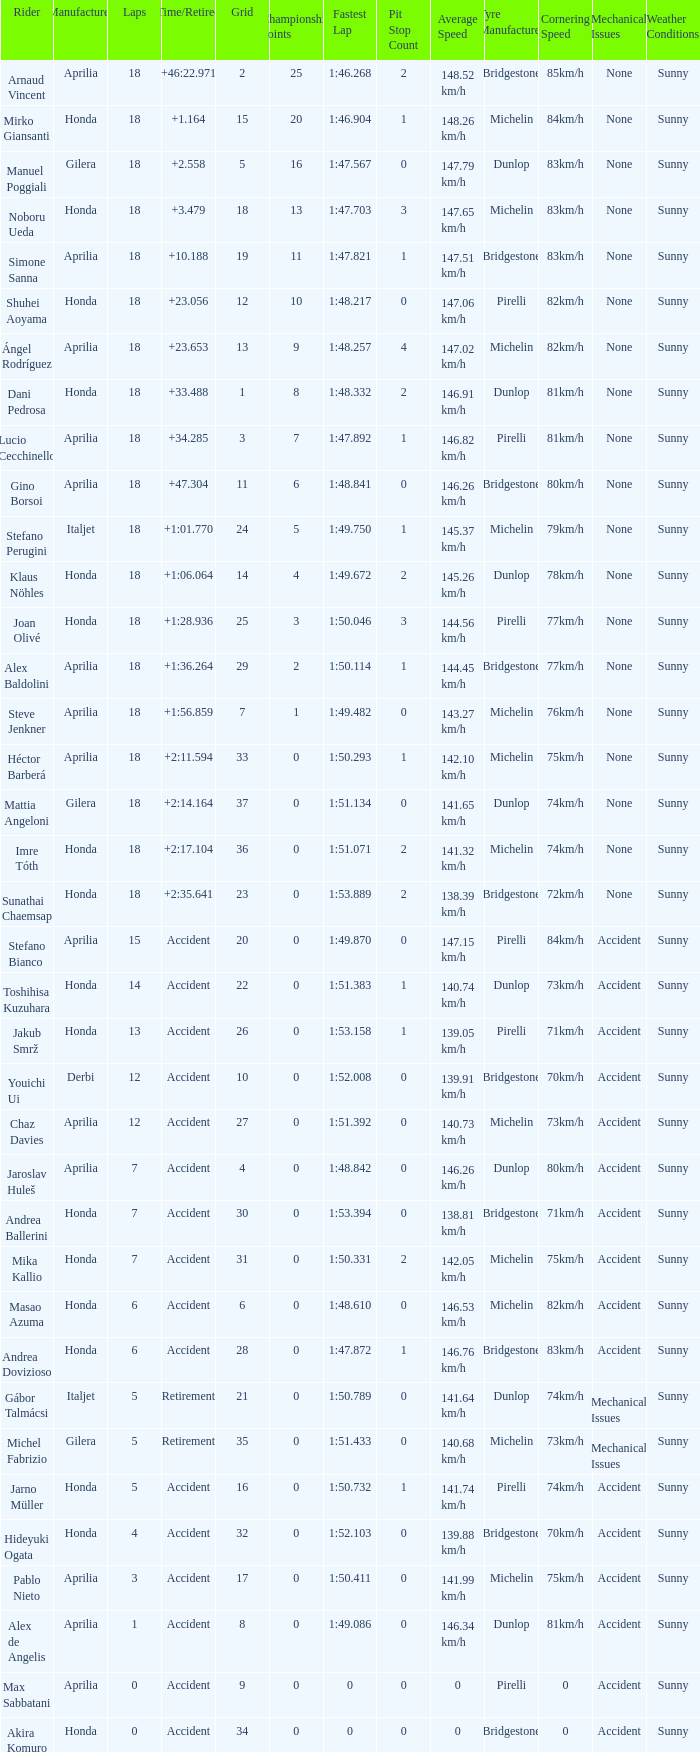What is the time/retired of the honda manufacturer with a grid less than 26, 18 laps, and joan olivé as the rider? +1:28.936. 